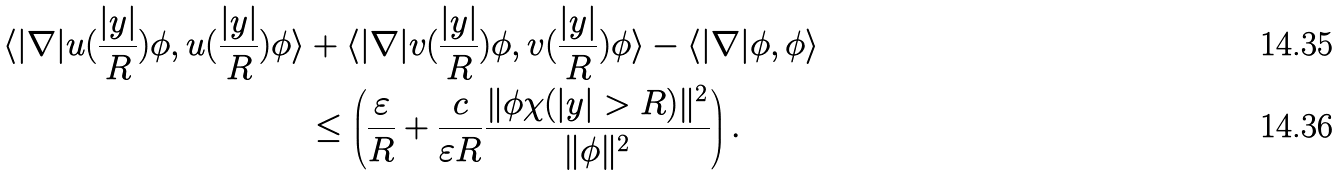Convert formula to latex. <formula><loc_0><loc_0><loc_500><loc_500>\langle | \nabla | u ( \frac { | y | } { R } ) \phi , u ( \frac { | y | } { R } ) \phi \rangle & + \langle | \nabla | v ( \frac { | y | } { R } ) \phi , v ( \frac { | y | } { R } ) \phi \rangle - \langle | \nabla | \phi , \phi \rangle \\ & \leq \left ( \frac { \varepsilon } { R } + \frac { c } { \varepsilon R } \frac { \| \phi \chi ( | y | > R ) \| ^ { 2 } } { \| \phi \| ^ { 2 } } \right ) .</formula> 